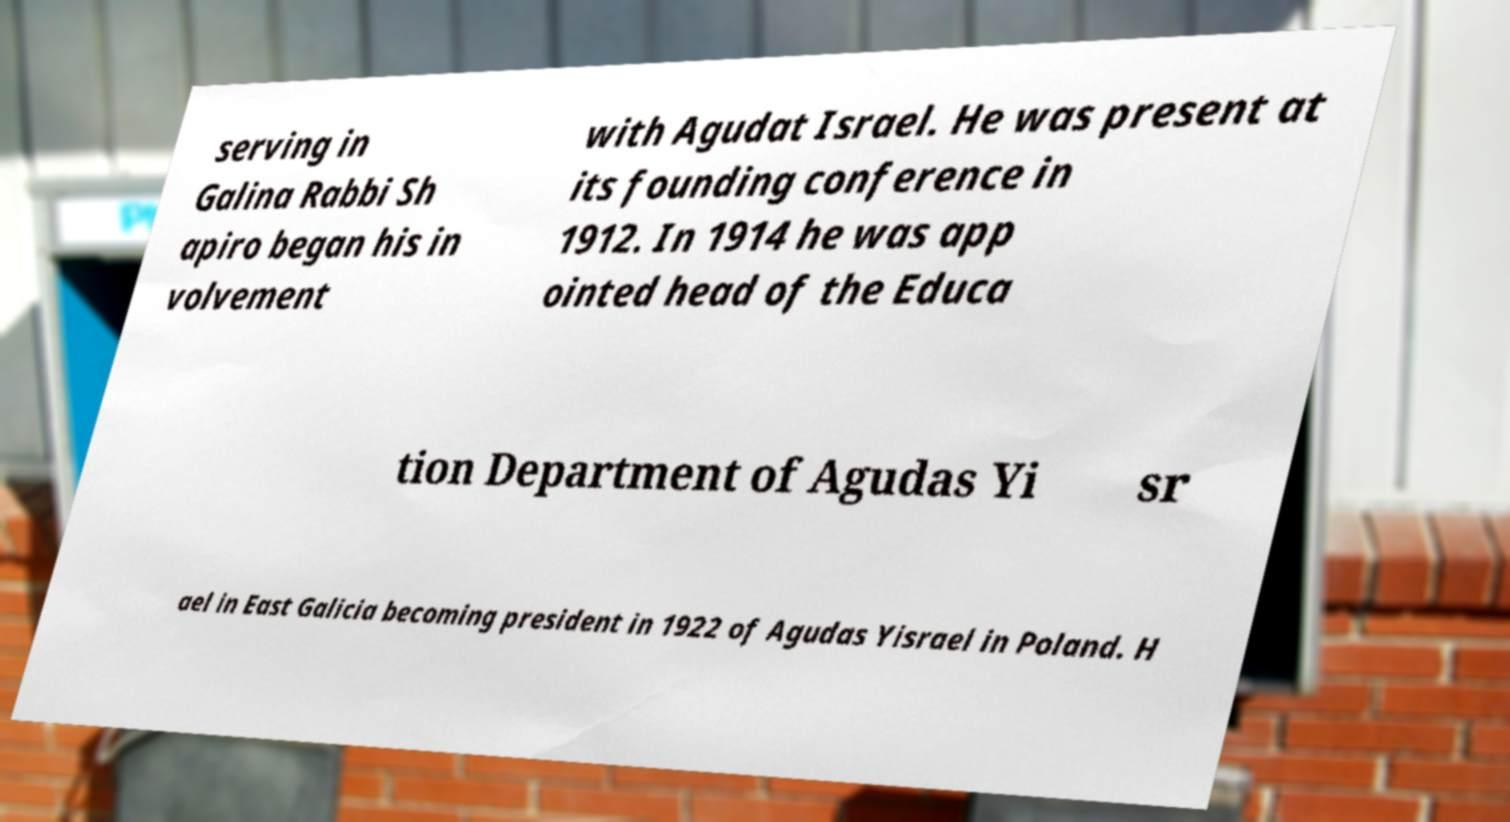Could you extract and type out the text from this image? serving in Galina Rabbi Sh apiro began his in volvement with Agudat Israel. He was present at its founding conference in 1912. In 1914 he was app ointed head of the Educa tion Department of Agudas Yi sr ael in East Galicia becoming president in 1922 of Agudas Yisrael in Poland. H 